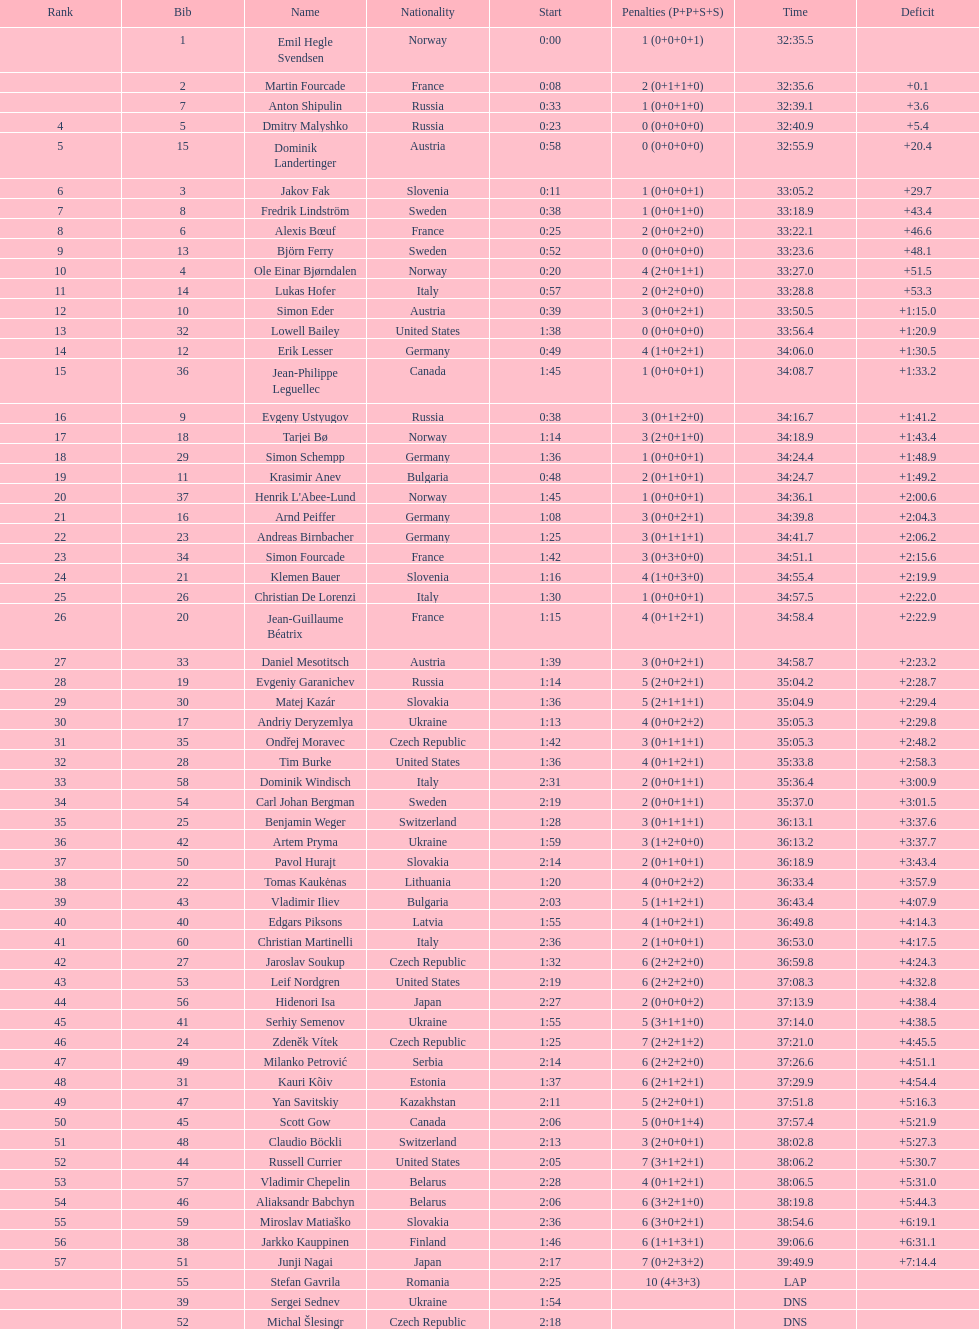What is the largest penalty? 10. 